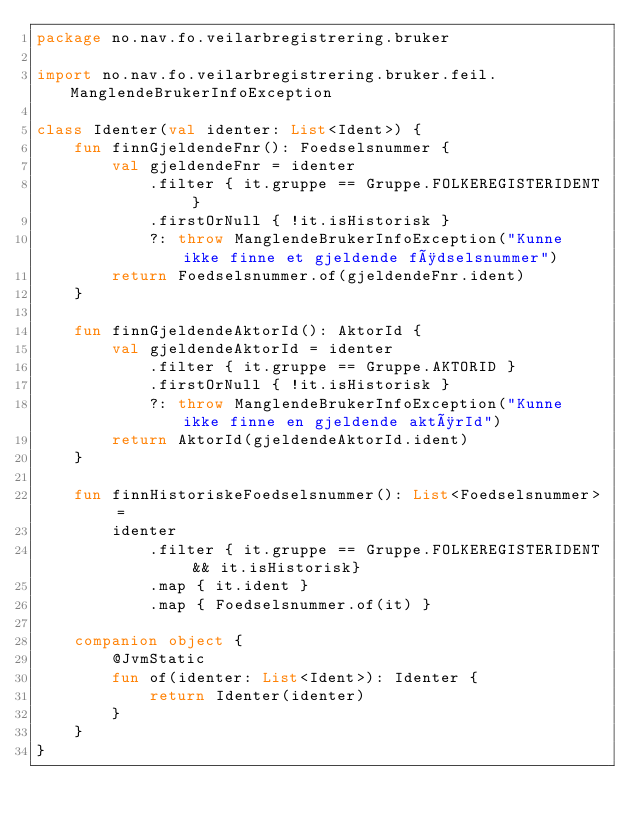Convert code to text. <code><loc_0><loc_0><loc_500><loc_500><_Kotlin_>package no.nav.fo.veilarbregistrering.bruker

import no.nav.fo.veilarbregistrering.bruker.feil.ManglendeBrukerInfoException

class Identer(val identer: List<Ident>) {
    fun finnGjeldendeFnr(): Foedselsnummer {
        val gjeldendeFnr = identer
            .filter { it.gruppe == Gruppe.FOLKEREGISTERIDENT }
            .firstOrNull { !it.isHistorisk }
            ?: throw ManglendeBrukerInfoException("Kunne ikke finne et gjeldende fødselsnummer")
        return Foedselsnummer.of(gjeldendeFnr.ident)
    }

    fun finnGjeldendeAktorId(): AktorId {
        val gjeldendeAktorId = identer
            .filter { it.gruppe == Gruppe.AKTORID }
            .firstOrNull { !it.isHistorisk }
            ?: throw ManglendeBrukerInfoException("Kunne ikke finne en gjeldende aktørId")
        return AktorId(gjeldendeAktorId.ident)
    }

    fun finnHistoriskeFoedselsnummer(): List<Foedselsnummer> =
        identer
            .filter { it.gruppe == Gruppe.FOLKEREGISTERIDENT && it.isHistorisk}
            .map { it.ident }
            .map { Foedselsnummer.of(it) }

    companion object {
        @JvmStatic
        fun of(identer: List<Ident>): Identer {
            return Identer(identer)
        }
    }
}</code> 